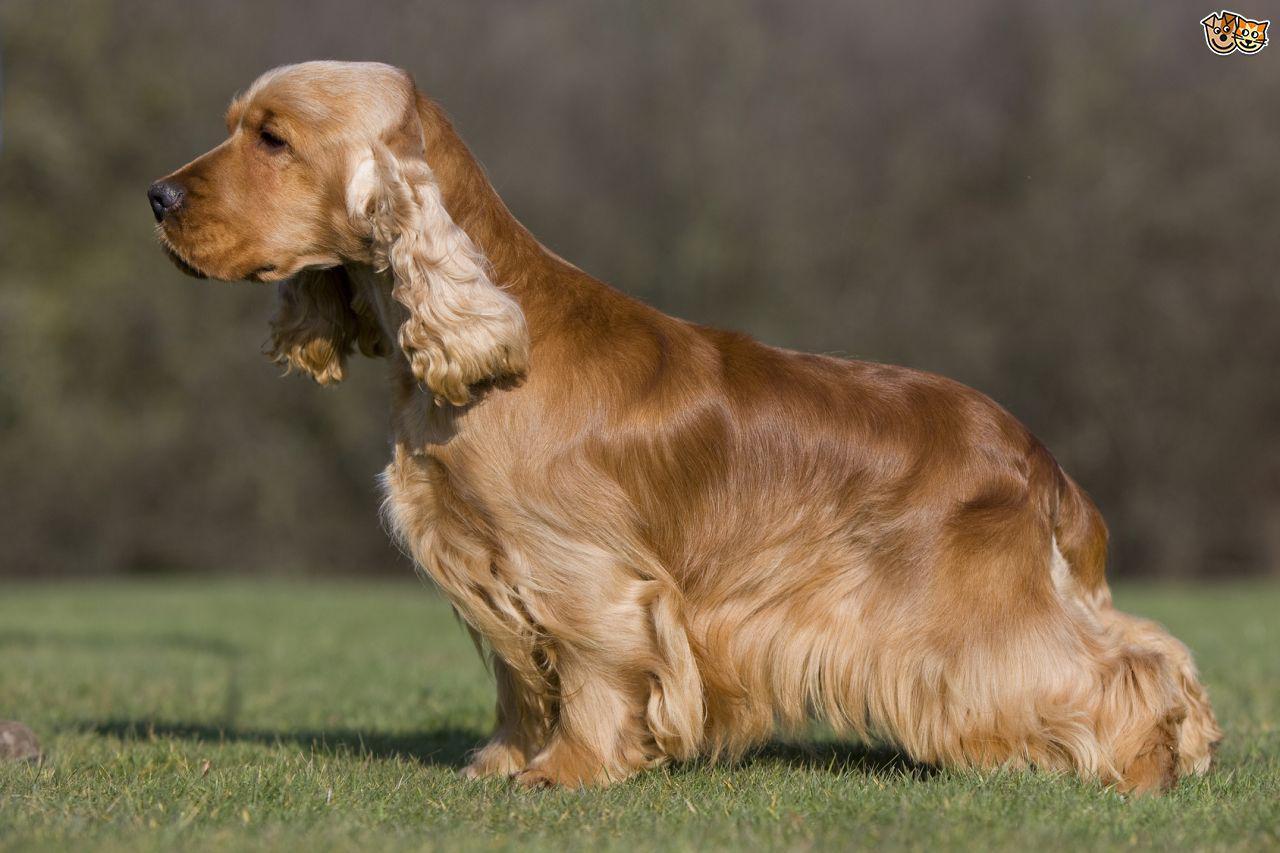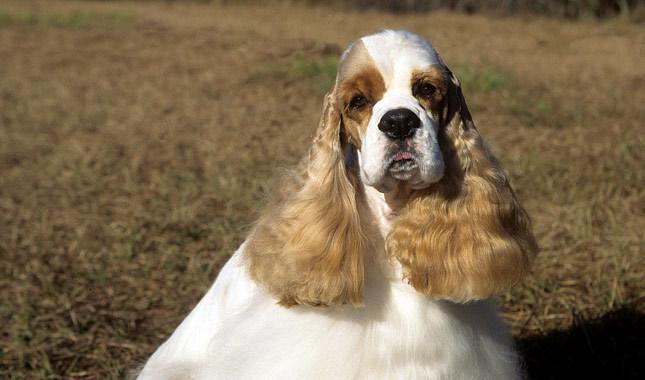The first image is the image on the left, the second image is the image on the right. Assess this claim about the two images: "The dog in the left image has a hair decoration.". Correct or not? Answer yes or no. No. 